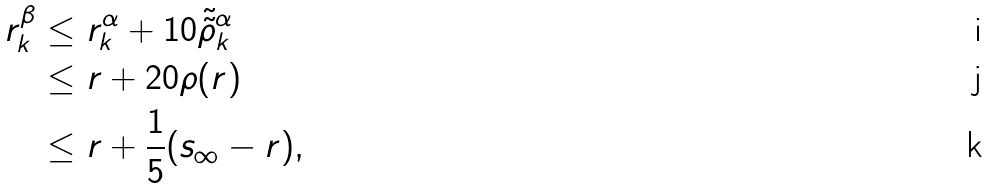Convert formula to latex. <formula><loc_0><loc_0><loc_500><loc_500>r _ { k } ^ { \beta } & \leq r _ { k } ^ { \alpha } + 1 0 \tilde { \tilde { \rho } } _ { k } ^ { \alpha } \\ & \leq r + 2 0 \rho ( r ) \\ & \leq r + \frac { 1 } { 5 } ( s _ { \infty } - r ) ,</formula> 